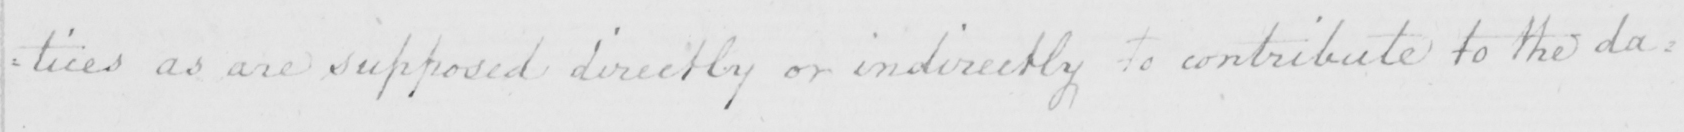What does this handwritten line say? : tices as are supposed directly or indirectly to contribute to the da= 